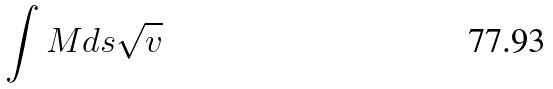<formula> <loc_0><loc_0><loc_500><loc_500>\int M d s \sqrt { v }</formula> 